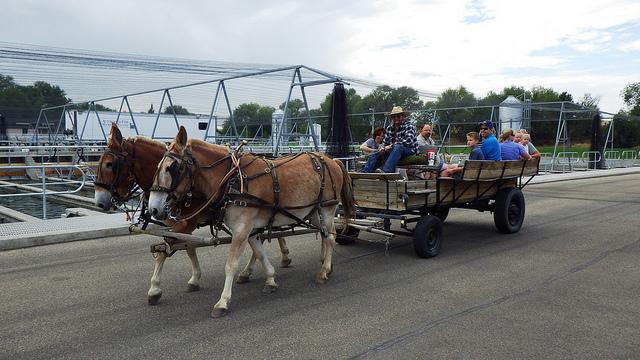Are there clouds in the sky?
Give a very brief answer. Yes. What are the horses pulling?
Be succinct. Wagon. Why do the horses wear black squares near their eyes?
Give a very brief answer. Protection. 